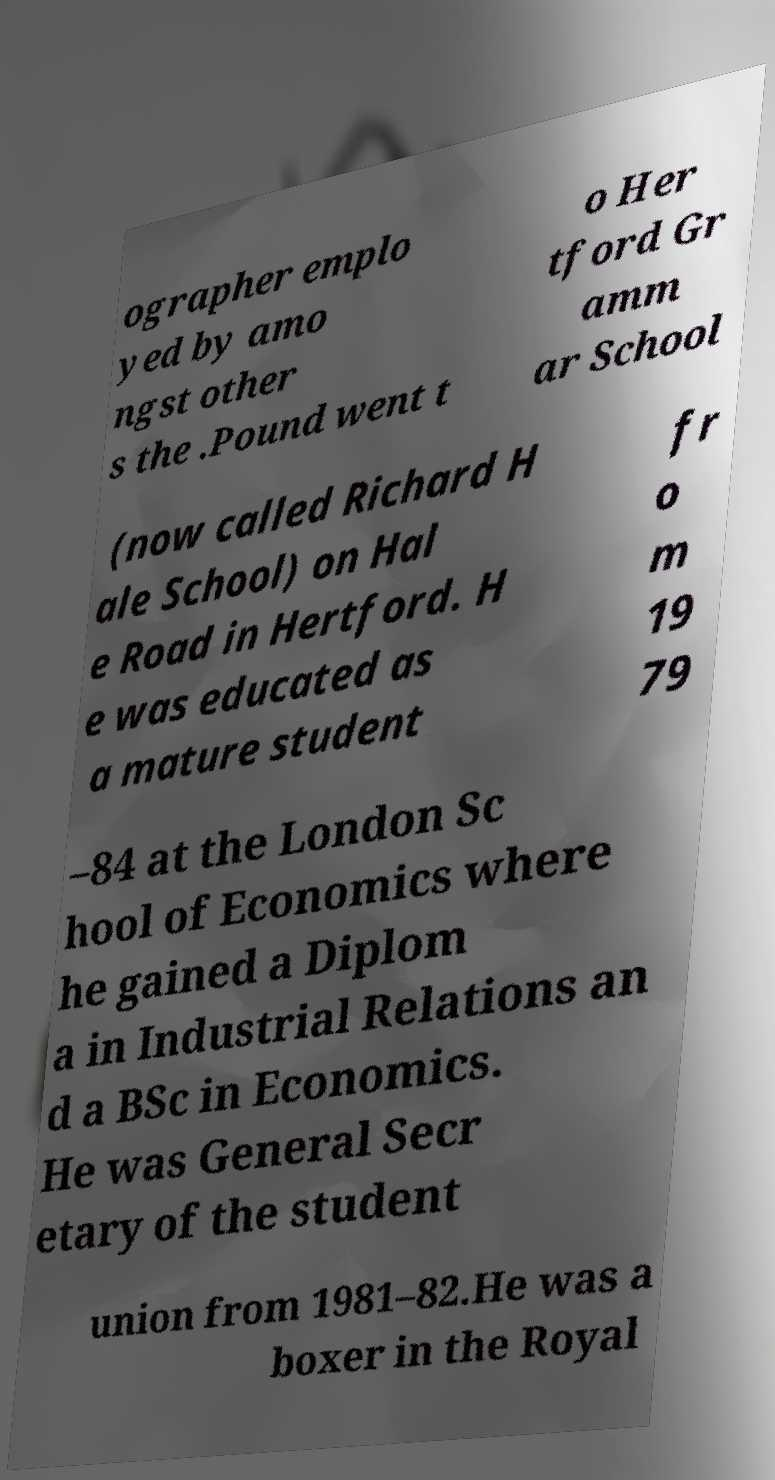Could you assist in decoding the text presented in this image and type it out clearly? ographer emplo yed by amo ngst other s the .Pound went t o Her tford Gr amm ar School (now called Richard H ale School) on Hal e Road in Hertford. H e was educated as a mature student fr o m 19 79 –84 at the London Sc hool of Economics where he gained a Diplom a in Industrial Relations an d a BSc in Economics. He was General Secr etary of the student union from 1981–82.He was a boxer in the Royal 